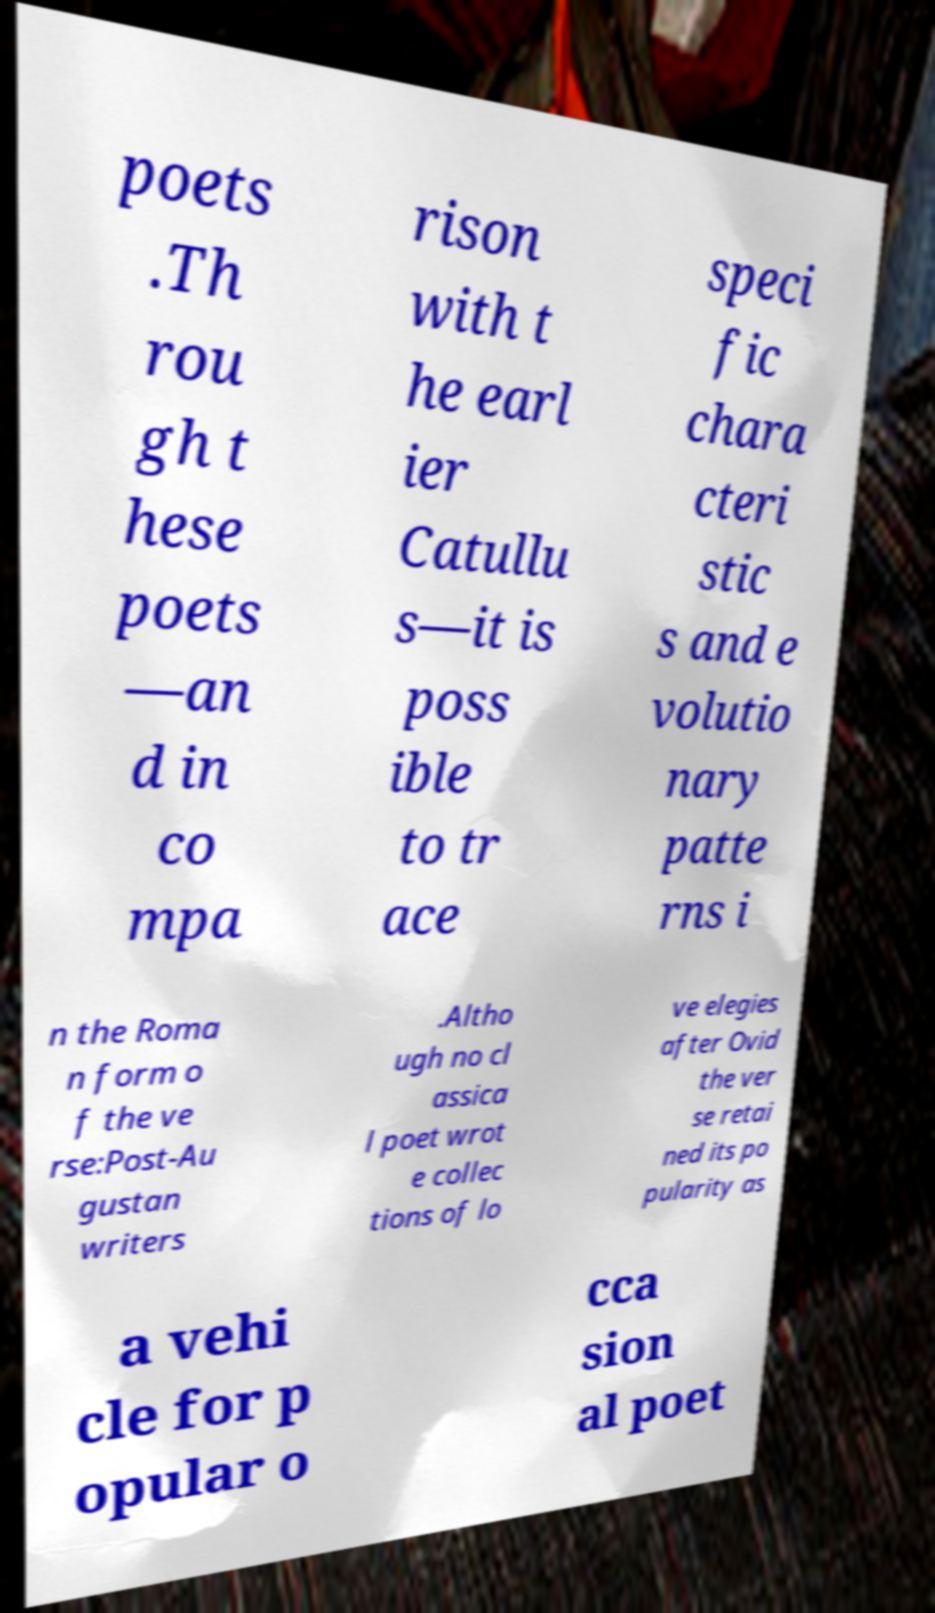What messages or text are displayed in this image? I need them in a readable, typed format. poets .Th rou gh t hese poets —an d in co mpa rison with t he earl ier Catullu s—it is poss ible to tr ace speci fic chara cteri stic s and e volutio nary patte rns i n the Roma n form o f the ve rse:Post-Au gustan writers .Altho ugh no cl assica l poet wrot e collec tions of lo ve elegies after Ovid the ver se retai ned its po pularity as a vehi cle for p opular o cca sion al poet 